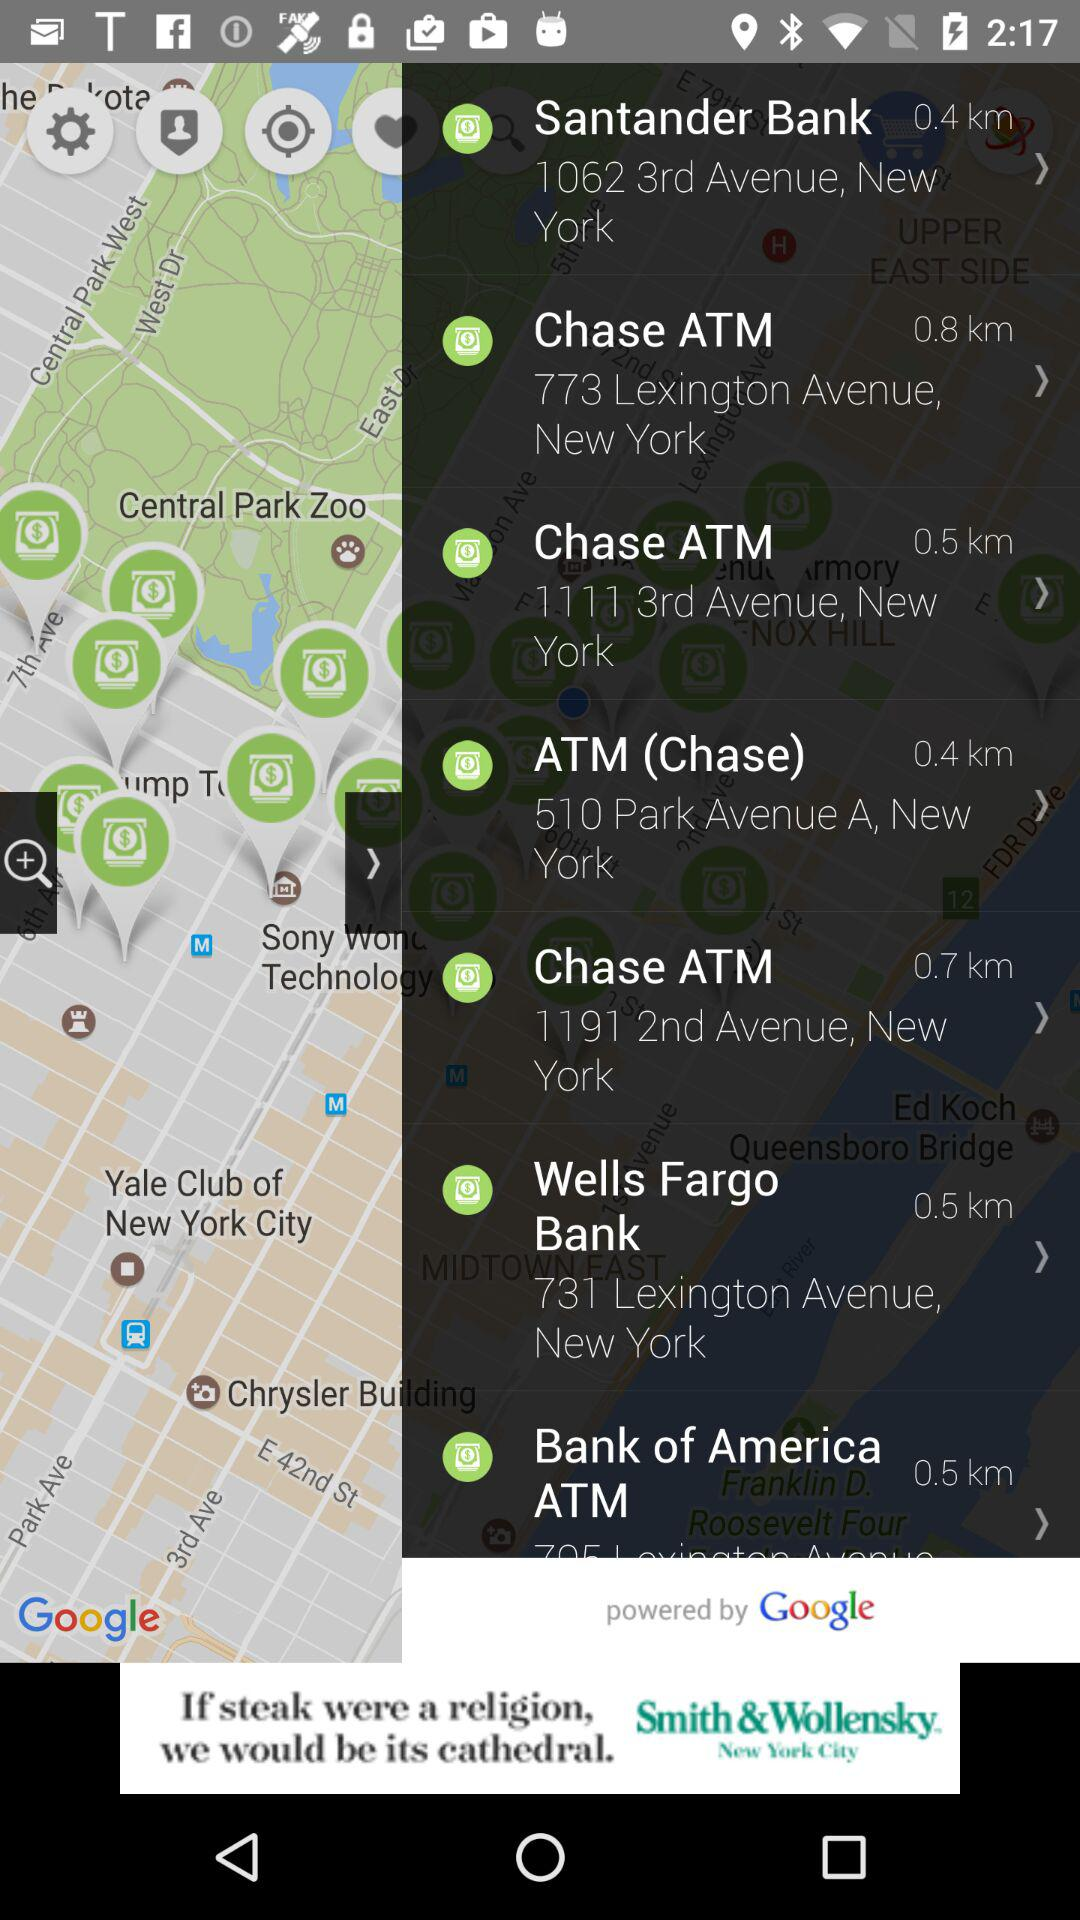How many meters away is the closest ATM?
Answer the question using a single word or phrase. 0.4 km 